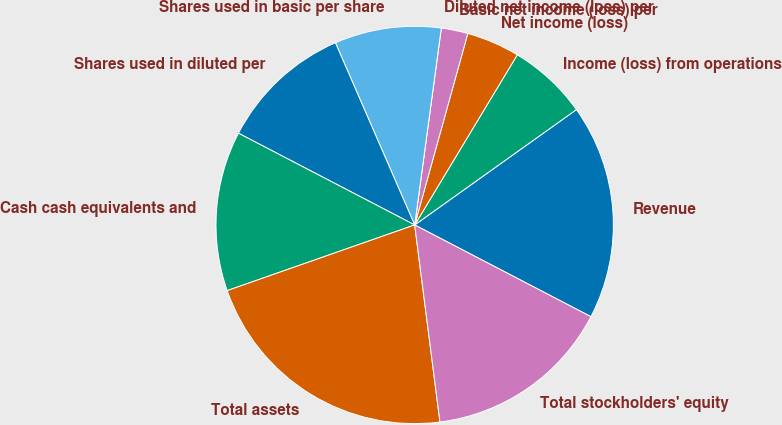<chart> <loc_0><loc_0><loc_500><loc_500><pie_chart><fcel>Revenue<fcel>Income (loss) from operations<fcel>Net income (loss)<fcel>Basic net income (loss) per<fcel>Diluted net income (loss) per<fcel>Shares used in basic per share<fcel>Shares used in diluted per<fcel>Cash cash equivalents and<fcel>Total assets<fcel>Total stockholders' equity<nl><fcel>17.5%<fcel>6.5%<fcel>4.33%<fcel>2.17%<fcel>0.0%<fcel>8.67%<fcel>10.83%<fcel>13.0%<fcel>21.67%<fcel>15.33%<nl></chart> 